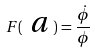<formula> <loc_0><loc_0><loc_500><loc_500>F ( \emph { a } ) = \frac { \dot { \phi } } { \phi }</formula> 